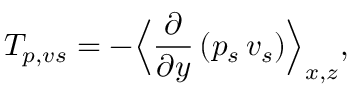<formula> <loc_0><loc_0><loc_500><loc_500>T _ { p , v s } = - \left \langle \frac { \partial } { \partial y } \left ( p _ { s } \, v _ { s } \right ) \right \rangle _ { x , z } ,</formula> 